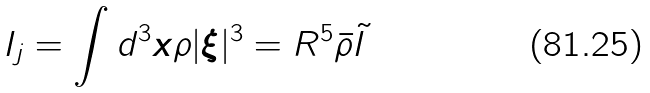Convert formula to latex. <formula><loc_0><loc_0><loc_500><loc_500>I _ { j } = \int d ^ { 3 } { \boldsymbol x } \rho | { \boldsymbol \xi } | ^ { 3 } = R ^ { 5 } \bar { \rho } \tilde { I }</formula> 